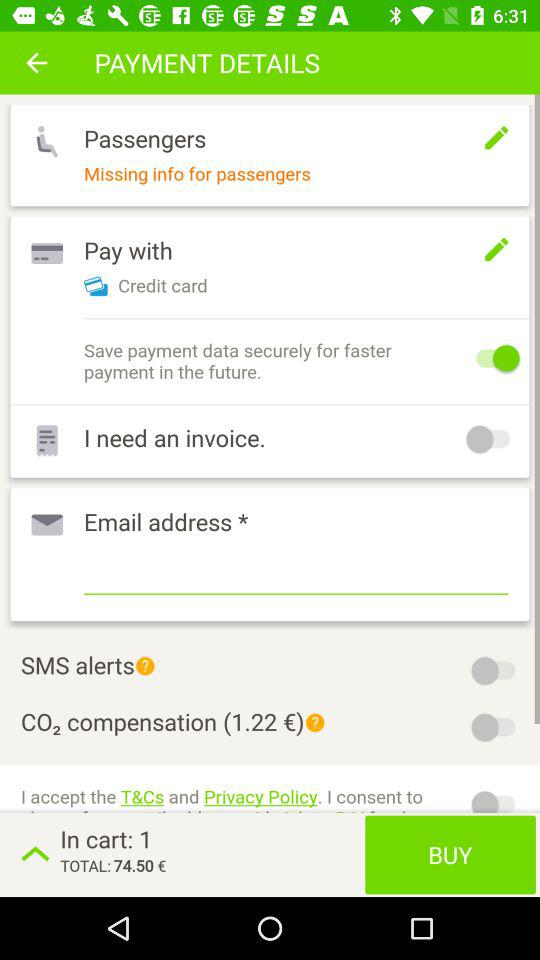How many items are in my cart?
Answer the question using a single word or phrase. 1 